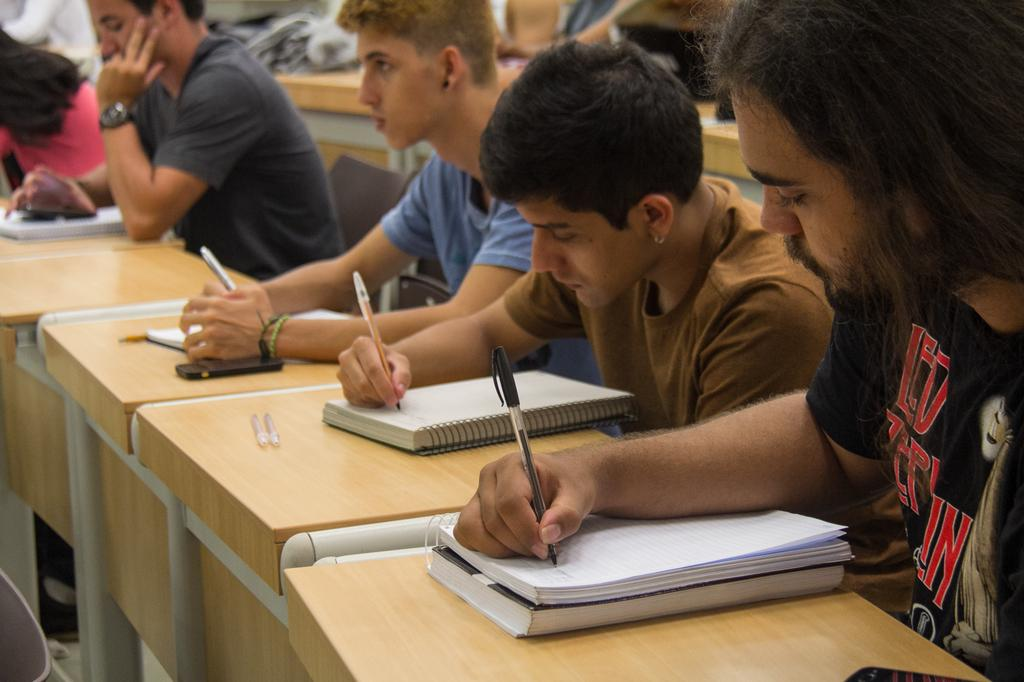<image>
Create a compact narrative representing the image presented. A bearded man with a large N on his shirt is writing in a notebook. 